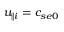<formula> <loc_0><loc_0><loc_500><loc_500>u _ { \| i } = c _ { s e 0 }</formula> 